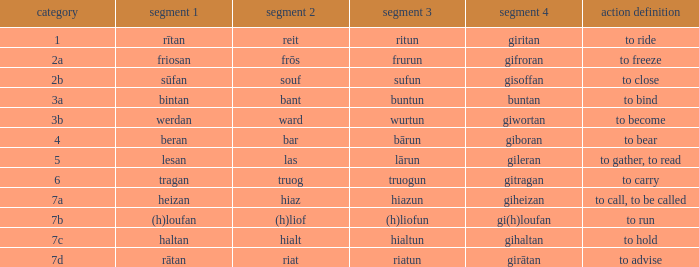What is the part 4 of the word with the part 1 "heizan"? Giheizan. 